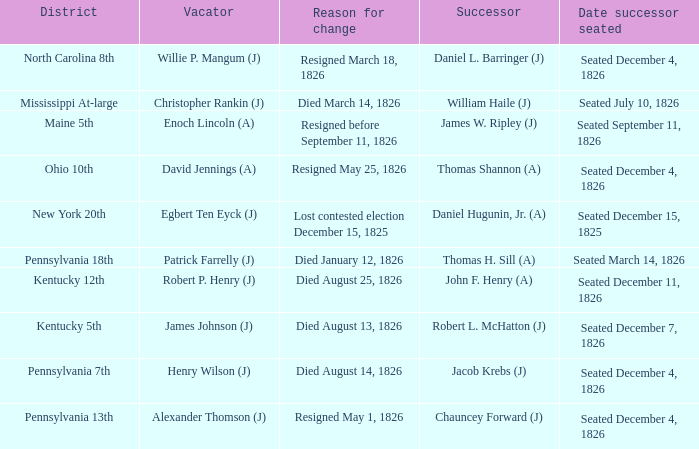Name the vacator for died august 13, 1826 James Johnson (J). 